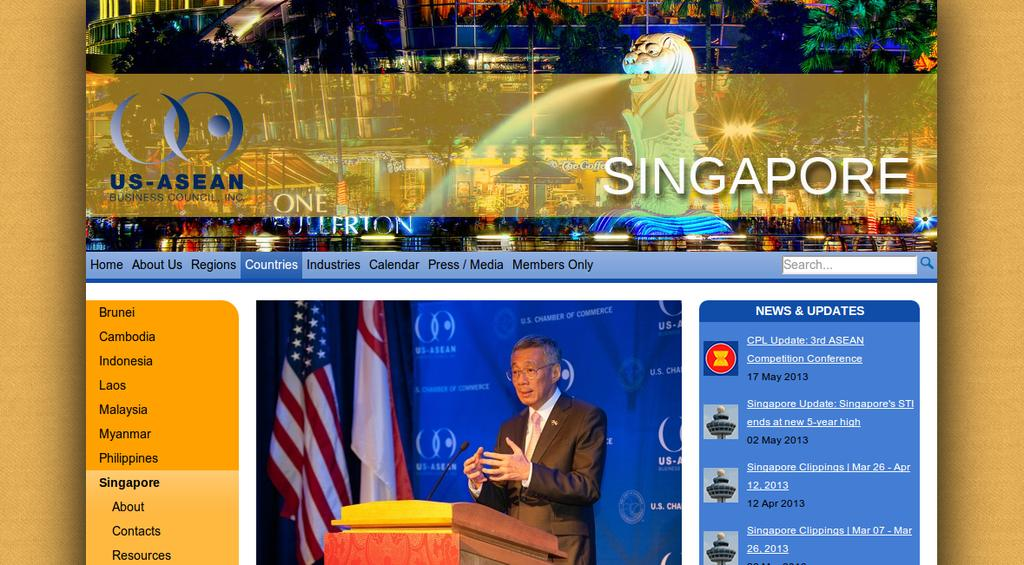<image>
Relay a brief, clear account of the picture shown. A web site with a photo of a man at a podium and the headline US-ASEAN at the top left. 